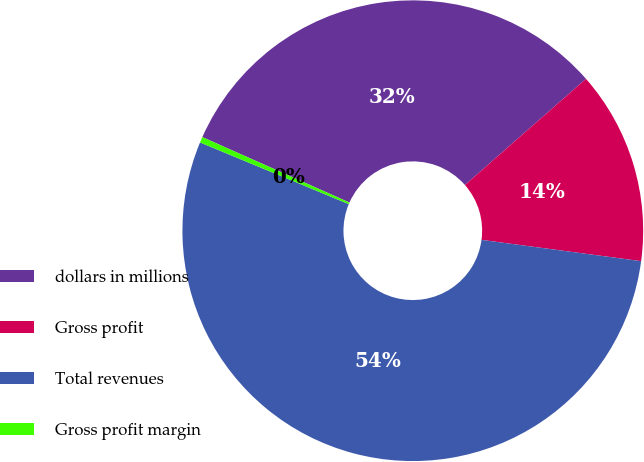Convert chart. <chart><loc_0><loc_0><loc_500><loc_500><pie_chart><fcel>dollars in millions<fcel>Gross profit<fcel>Total revenues<fcel>Gross profit margin<nl><fcel>31.88%<fcel>13.57%<fcel>54.15%<fcel>0.4%<nl></chart> 